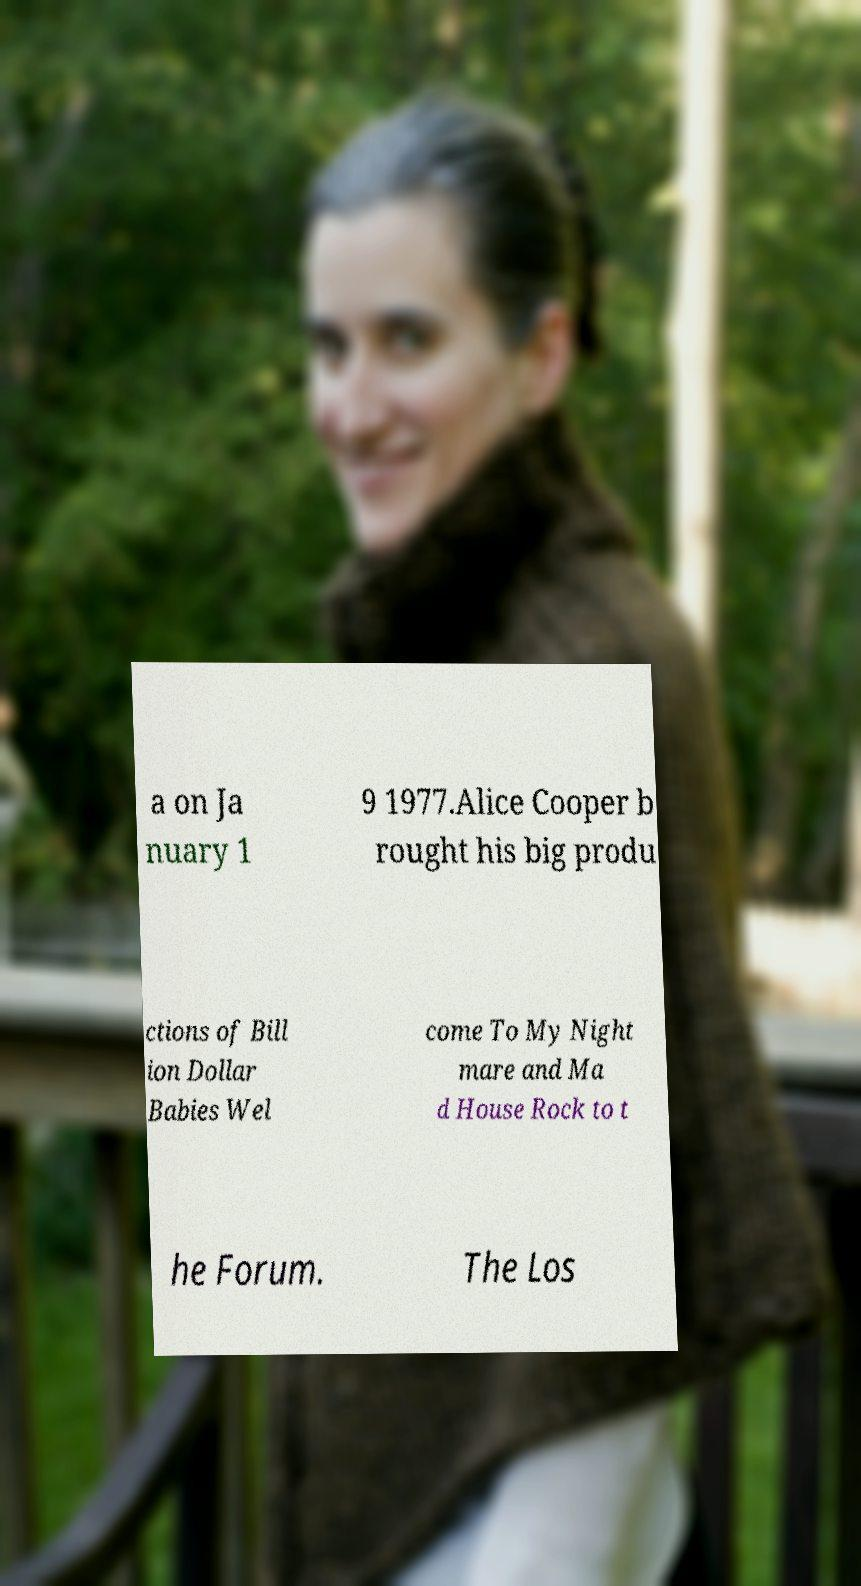Can you accurately transcribe the text from the provided image for me? a on Ja nuary 1 9 1977.Alice Cooper b rought his big produ ctions of Bill ion Dollar Babies Wel come To My Night mare and Ma d House Rock to t he Forum. The Los 